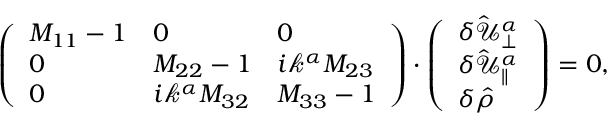Convert formula to latex. <formula><loc_0><loc_0><loc_500><loc_500>\begin{array} { r } { \left ( \begin{array} { l l l } { M _ { 1 1 } - 1 } & { 0 } & { 0 } \\ { 0 } & { M _ { 2 2 } - 1 } & { i \mathcal { k } ^ { \alpha } M _ { 2 3 } } \\ { 0 } & { i \mathcal { k } ^ { \alpha } M _ { 3 2 } } & { M _ { 3 3 } - 1 } \end{array} \right ) \cdot \left ( \begin{array} { l } { \delta \hat { \mathcal { U } } _ { \perp } ^ { \alpha } } \\ { \delta \hat { \mathcal { U } } _ { \| } ^ { \alpha } } \\ { \delta \hat { \rho } } \end{array} \right ) = 0 , } \end{array}</formula> 